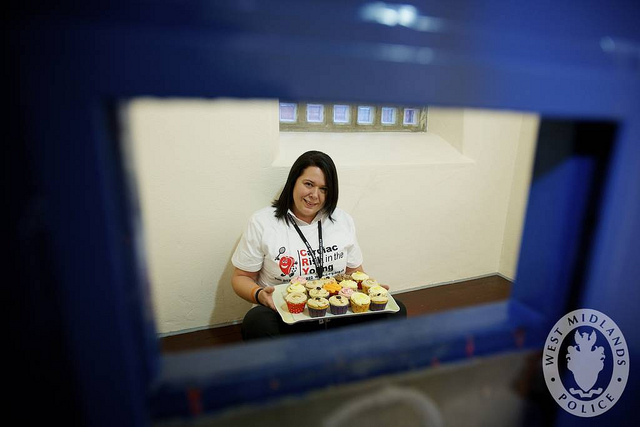<image>Who wants her food? It is unknown who wants her food. The responses suggest it could be a girl, prisoner, police, no one, or woman. What website is stamped on this photo? I am not sure which website is stamped on the photo. It could be 'west midland police', 'west midlands police', or 'weight watchers'. What cookies are on the table? There are no cookies on the table. However, there are cupcakes. Who wants her food? I am not sure who wants her food. It can be the girl, the prison guard, the prisoner, the police, the woman, or the inmate. What cookies are on the table? I don't know what cookies are on the table. It could be cupcakes or there may be no cookies at all. What website is stamped on this photo? I don't know what website is stamped on this photo. It can be any of the following: 'west midland police', 'west midlands', 'west midlands police', 'west midlands police', 'west midlands police', 'west midlands police', 'weight watchers', 'west midland police', 'police', or 'none'. 